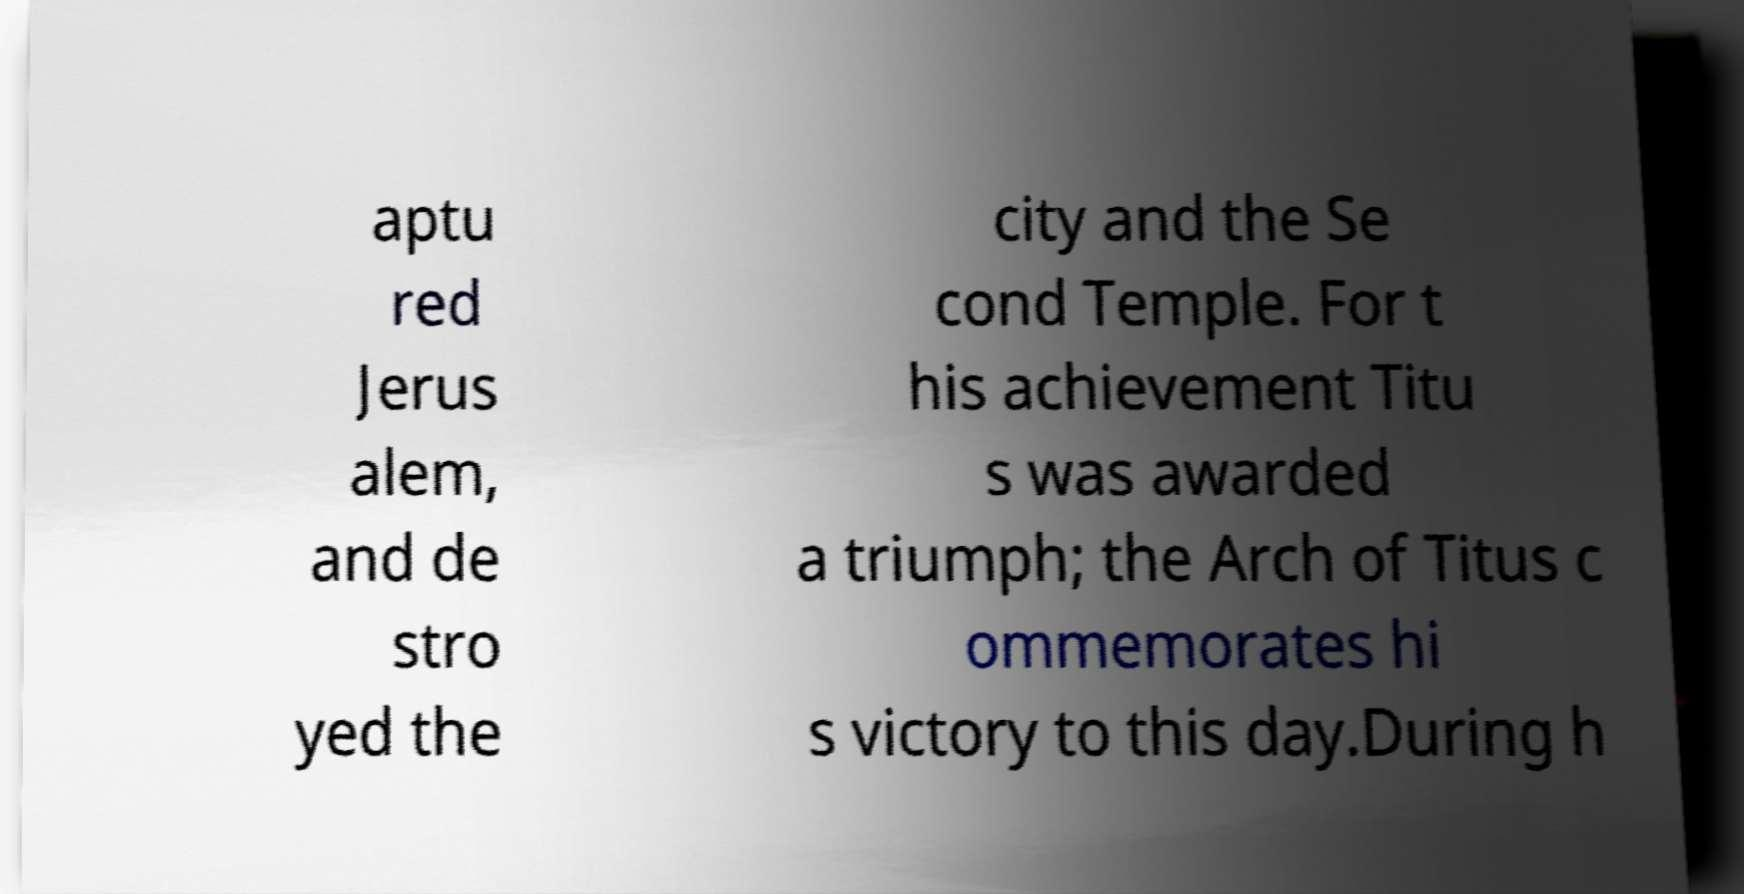Could you extract and type out the text from this image? aptu red Jerus alem, and de stro yed the city and the Se cond Temple. For t his achievement Titu s was awarded a triumph; the Arch of Titus c ommemorates hi s victory to this day.During h 